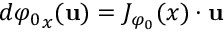Convert formula to latex. <formula><loc_0><loc_0><loc_500><loc_500>d { \varphi _ { 0 } } _ { x } ( { u } ) = J _ { \varphi _ { 0 } } ( x ) \cdot { u }</formula> 